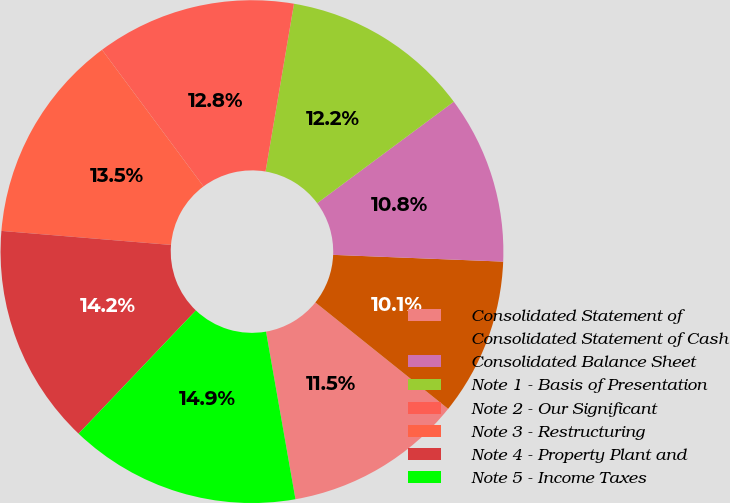Convert chart to OTSL. <chart><loc_0><loc_0><loc_500><loc_500><pie_chart><fcel>Consolidated Statement of<fcel>Consolidated Statement of Cash<fcel>Consolidated Balance Sheet<fcel>Note 1 - Basis of Presentation<fcel>Note 2 - Our Significant<fcel>Note 3 - Restructuring<fcel>Note 4 - Property Plant and<fcel>Note 5 - Income Taxes<nl><fcel>11.48%<fcel>10.12%<fcel>10.8%<fcel>12.16%<fcel>12.84%<fcel>13.52%<fcel>14.2%<fcel>14.88%<nl></chart> 